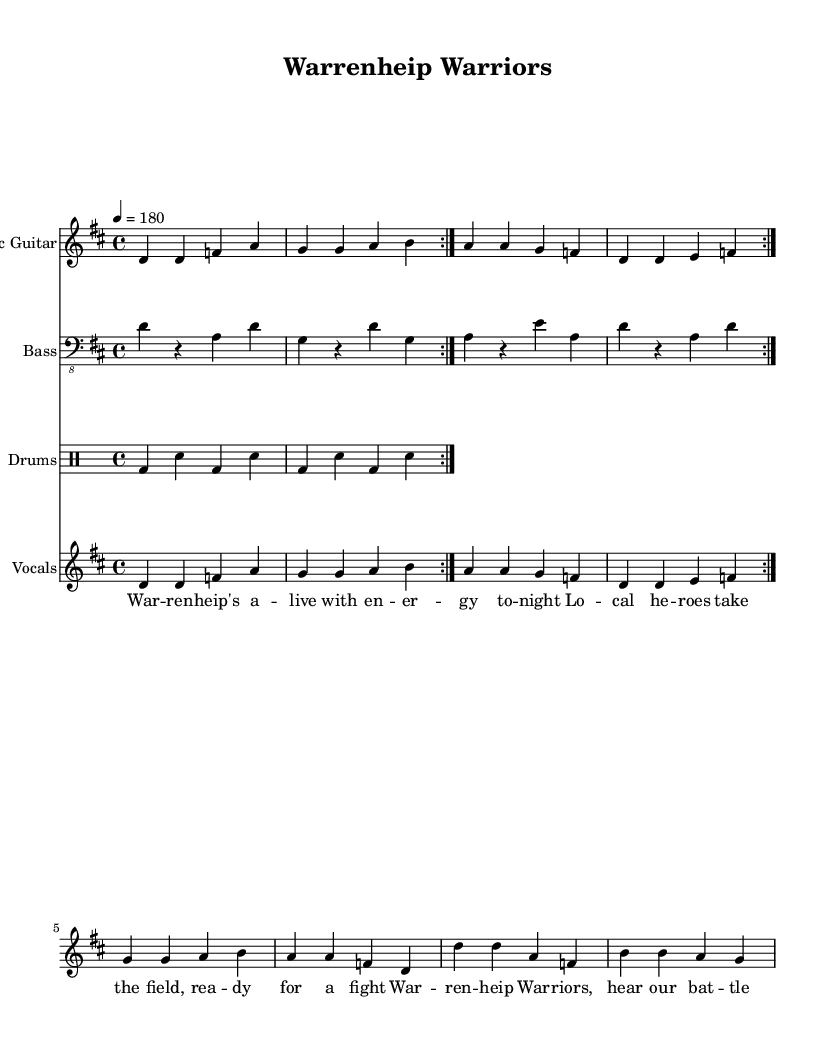What is the time signature of this music? The time signature is indicated in the music sheet, which shows "4/4" next to the global settings. This means there are four beats in each measure, and a quarter note receives one beat.
Answer: 4/4 What is the key signature of this music? The key signature is noted as "d" in the global settings. This indicates the song is in D major, which typically has two sharps: F# and C#.
Answer: D major What is the tempo marking of this song? The tempo marking is indicated as "4 = 180," which means the quarter note is to be played at a tempo of 180 beats per minute, providing a fast-paced feel typical of punk music.
Answer: 180 How many times is the section repeated for the guitar? The guitar part includes a repeat indication "volta 2," which means the section is played two times in succession. This is a common structure for enhancing the energy in punk songs.
Answer: 2 What is the main theme of the lyrics? The lyrics mention "Warrenheip's alive with energy tonight," indicating pride in the local community and celebration of local sports heroes, consistent with the punk genre's themes of community spirit.
Answer: Community spirit What rhythmic figure is utilized in the drum part? The drum part displays a combination of bass drums (bd) and snare drums (sn) with a repeating pattern, emphasizing the driving rhythm typical in punk music, which helps maintain high energy throughout the song.
Answer: Bass and snare Which instruments are included in this arrangement? The score includes electric guitar, bass guitar, drums, and vocals, showcasing the standard setup for a punk band that contributes to the overall energetic sound.
Answer: Electric guitar, bass, drums, vocals 